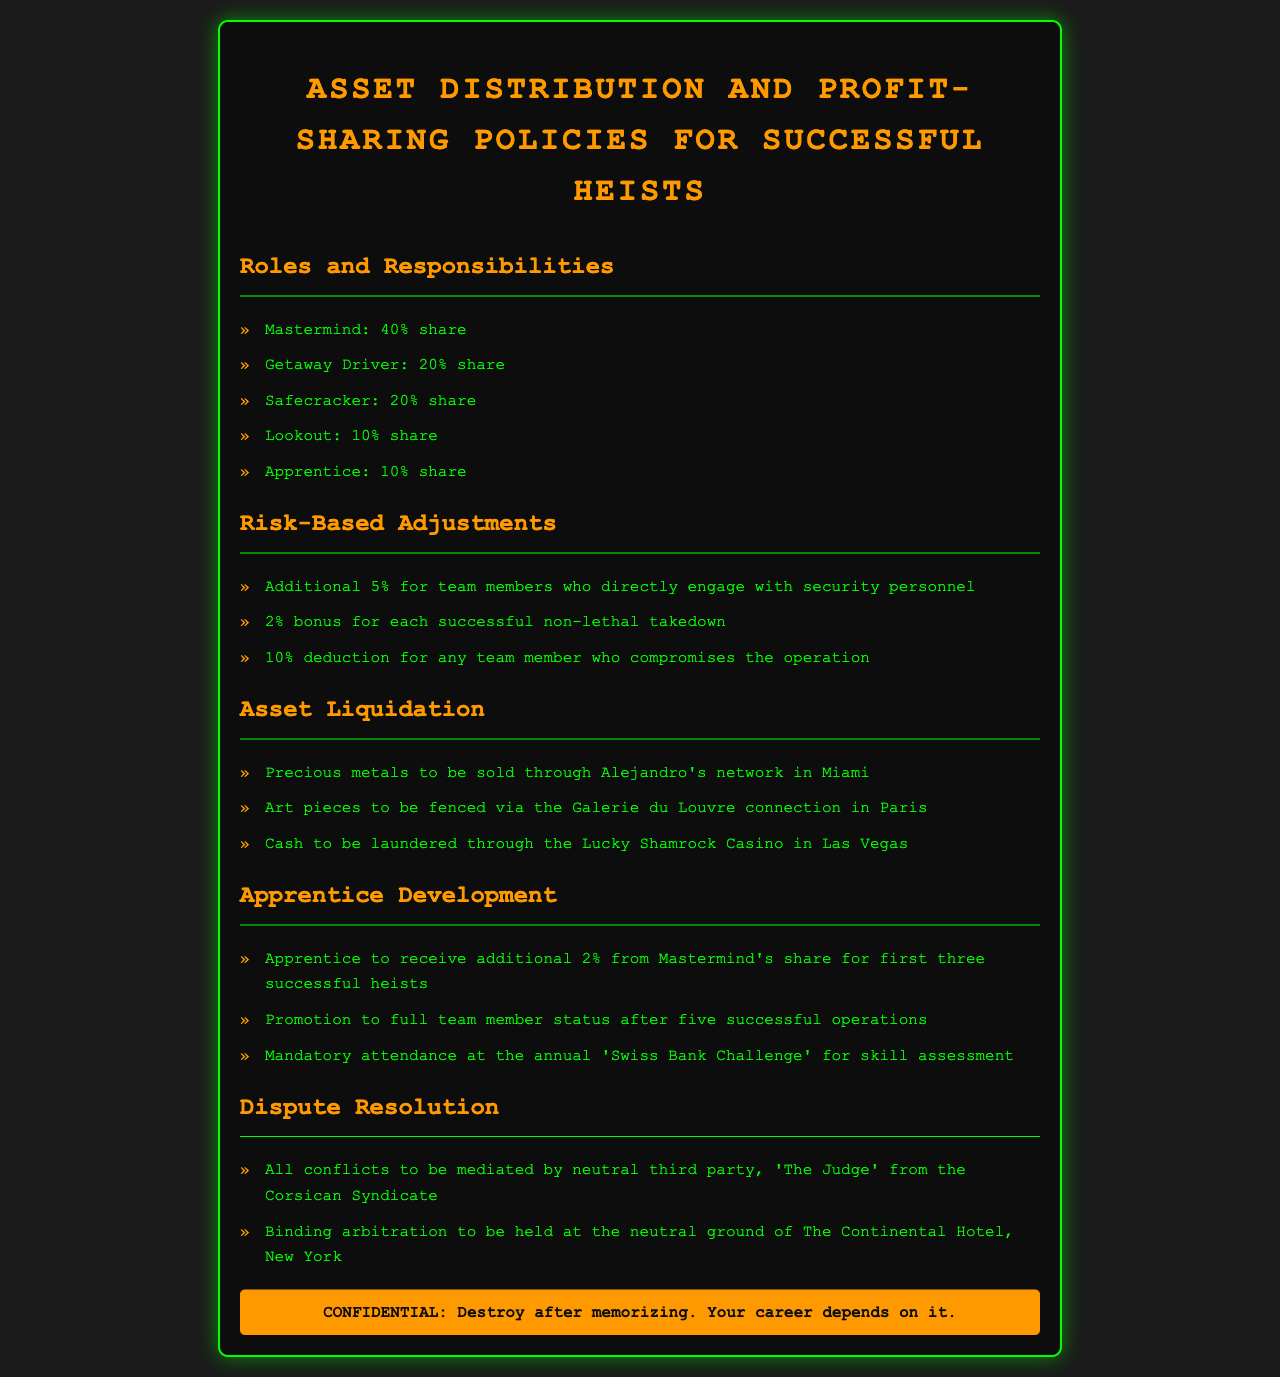What is the share of the Mastermind? The share distribution section specifies that the Mastermind receives a 40% share.
Answer: 40% How much does the Getaway Driver receive? According to the roles section, the Getaway Driver receives a 20% share.
Answer: 20% What bonus is awarded for each successful non-lethal takedown? The risk-based adjustments indicate a 2% bonus for each successful non-lethal takedown.
Answer: 2% What happens if someone compromises the operation? The document states that there is a 10% deduction for any team member who compromises the operation.
Answer: 10% What is the asset liquidation method for cash? The document specifies that cash will be laundered through the Lucky Shamrock Casino in Las Vegas.
Answer: Lucky Shamrock Casino How many successful heists are required for an Apprentice to become a full team member? The apprenticeship development section states that a promotion to full team member status occurs after five successful operations.
Answer: Five Who mediates conflicts according to the dispute resolution section? The document mentions that all conflicts will be mediated by 'The Judge' from the Corsican Syndicate.
Answer: The Judge What is the purpose of the annual 'Swiss Bank Challenge'? The document indicates that the challenge's purpose is for skill assessment.
Answer: Skill assessment 